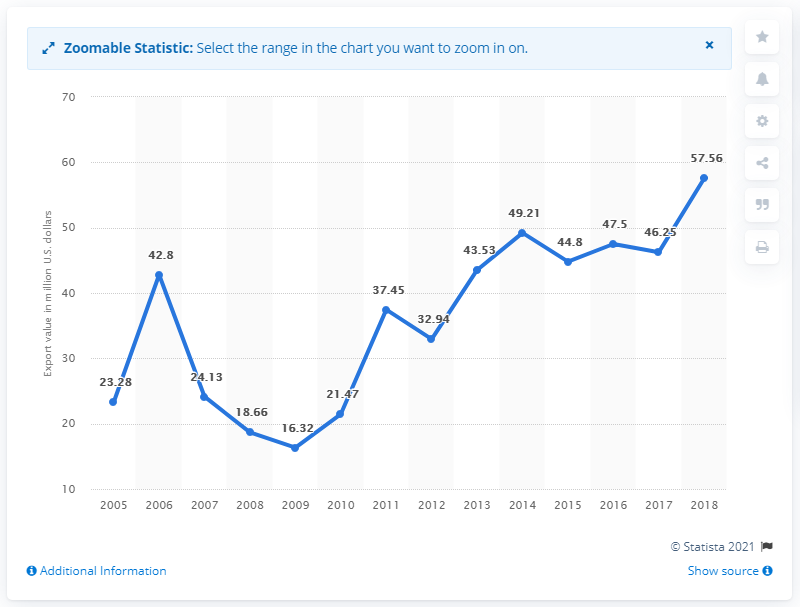Give some essential details in this illustration. The first two years are different by 19.52. The United States exported $57.56 million worth of pajamas and nightwear to the rest of the world in 2018. In 2009, the United States exported $16.32 billion worth of pajamas and nightwear to other countries. In the year 2015, the value was 44.8. 